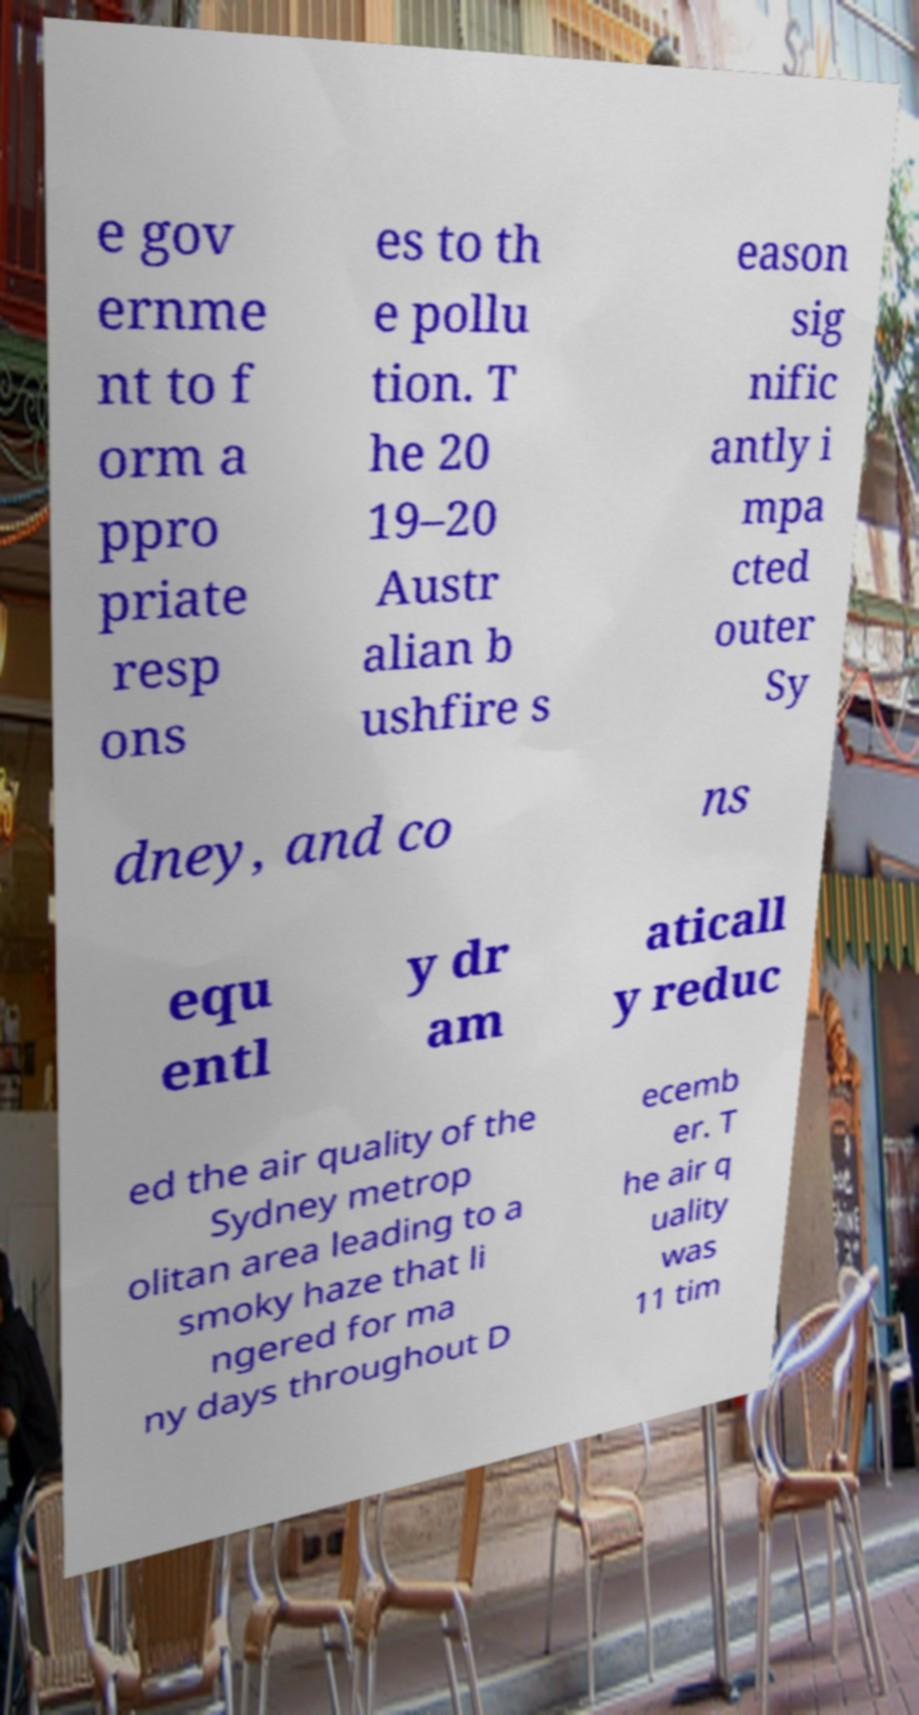For documentation purposes, I need the text within this image transcribed. Could you provide that? e gov ernme nt to f orm a ppro priate resp ons es to th e pollu tion. T he 20 19–20 Austr alian b ushfire s eason sig nific antly i mpa cted outer Sy dney, and co ns equ entl y dr am aticall y reduc ed the air quality of the Sydney metrop olitan area leading to a smoky haze that li ngered for ma ny days throughout D ecemb er. T he air q uality was 11 tim 